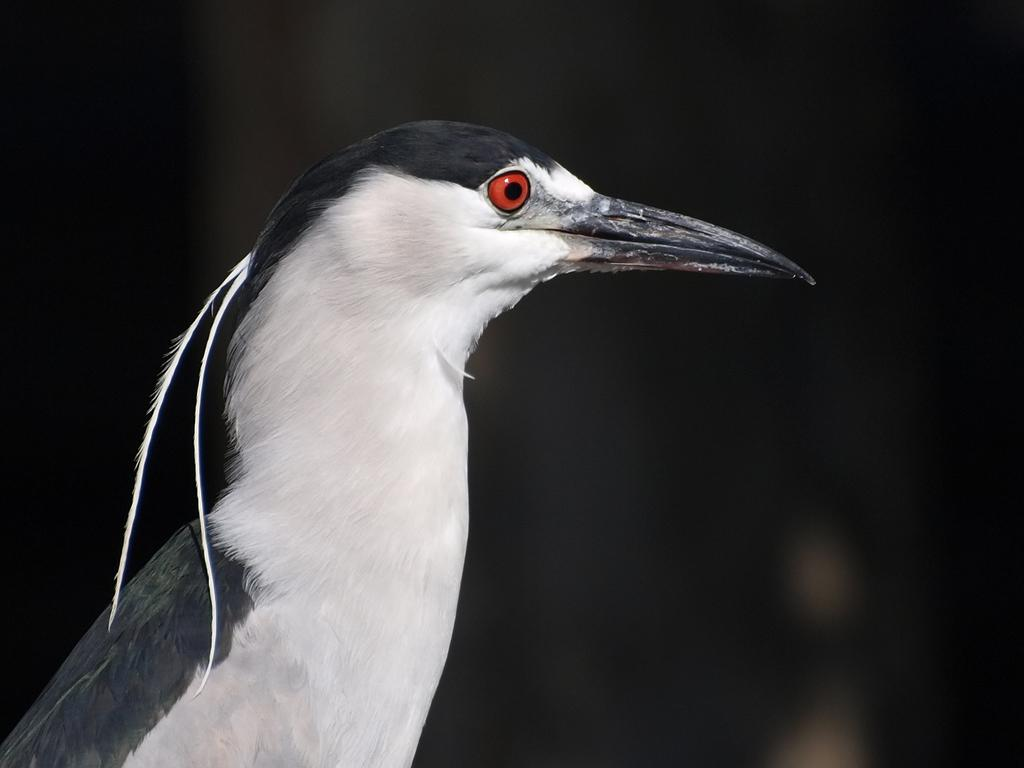What is the color of the background in the image? The background of the image is dark. What type of animal can be seen in the image? There is a bird in the image. What colors are present on the bird in the image? The bird is in white and black color. Can you see a border around the bird in the image? There is no mention of a border around the bird in the provided facts, so it cannot be determined from the image. Is there a basket visible in the image? There is no reference to a basket in the provided facts, so it cannot be determined from the image. 